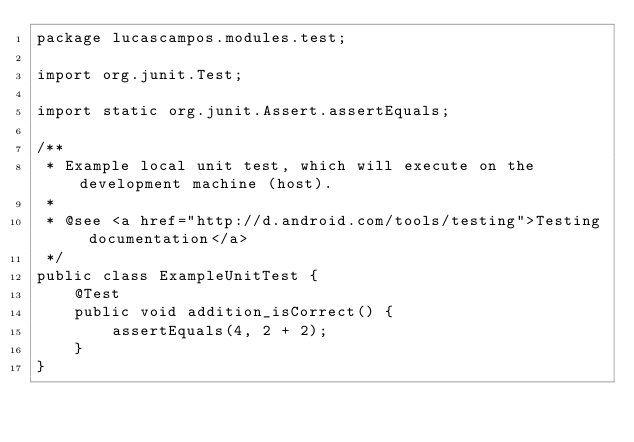<code> <loc_0><loc_0><loc_500><loc_500><_Java_>package lucascampos.modules.test;

import org.junit.Test;

import static org.junit.Assert.assertEquals;

/**
 * Example local unit test, which will execute on the development machine (host).
 *
 * @see <a href="http://d.android.com/tools/testing">Testing documentation</a>
 */
public class ExampleUnitTest {
    @Test
    public void addition_isCorrect() {
        assertEquals(4, 2 + 2);
    }
}</code> 